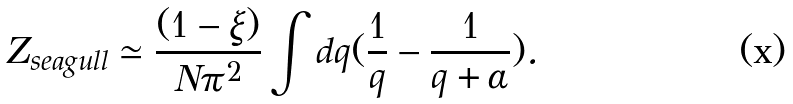<formula> <loc_0><loc_0><loc_500><loc_500>Z _ { s e a g u l l } \simeq \frac { ( 1 - \xi ) } { N \pi ^ { 2 } } \int d q ( \frac { 1 } { q } - \frac { 1 } { q + \alpha } ) .</formula> 